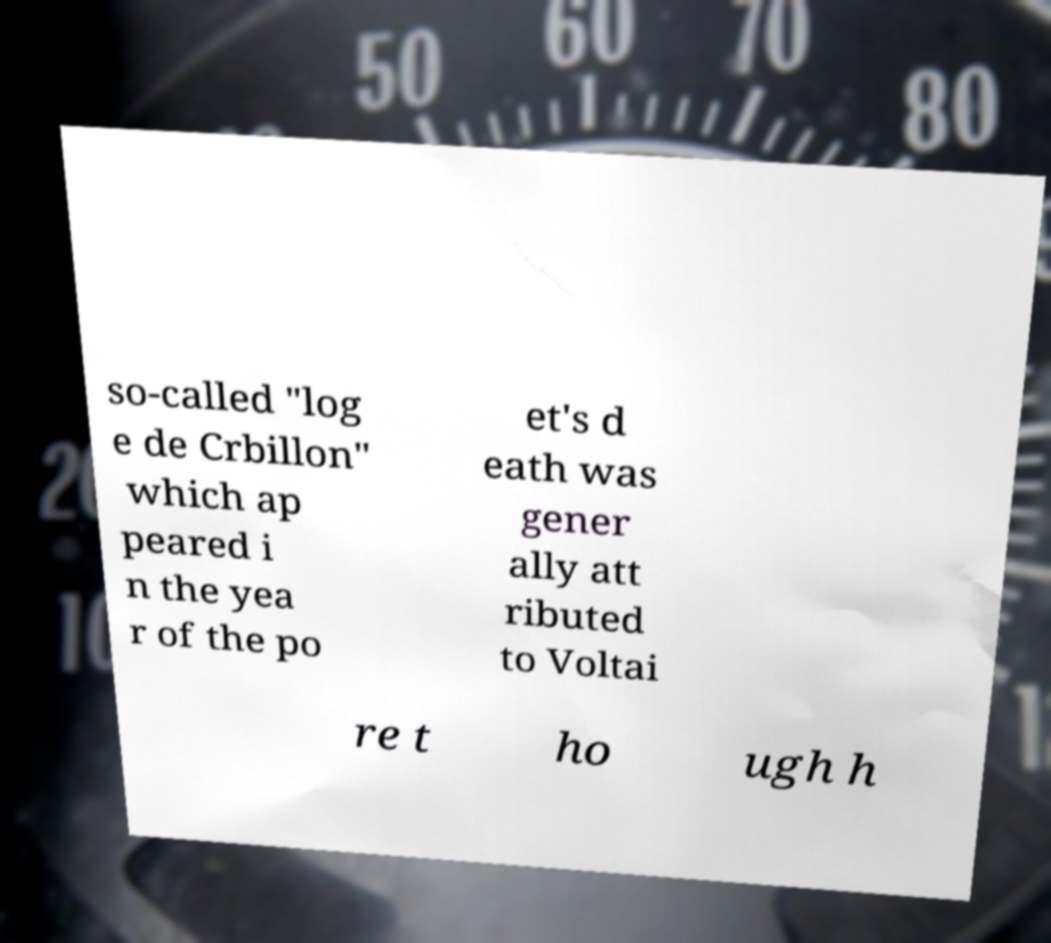What messages or text are displayed in this image? I need them in a readable, typed format. so-called "log e de Crbillon" which ap peared i n the yea r of the po et's d eath was gener ally att ributed to Voltai re t ho ugh h 